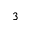Convert formula to latex. <formula><loc_0><loc_0><loc_500><loc_500>^ { 3 }</formula> 